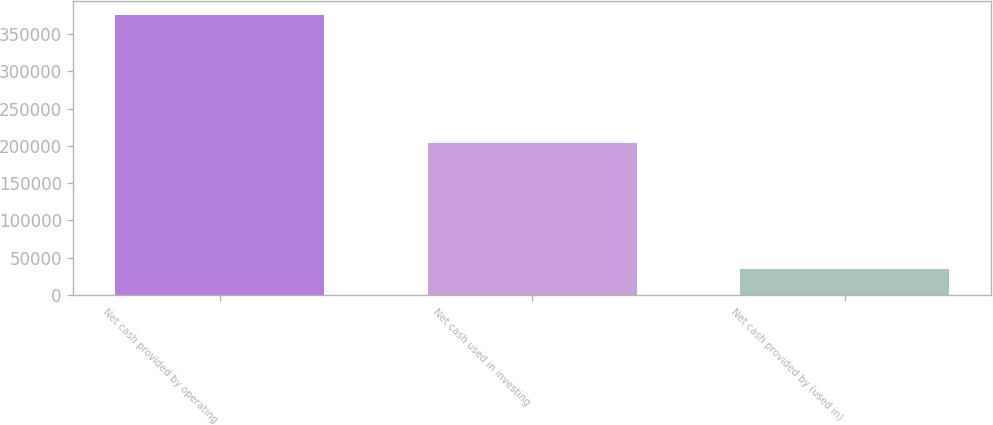Convert chart. <chart><loc_0><loc_0><loc_500><loc_500><bar_chart><fcel>Net cash provided by operating<fcel>Net cash used in investing<fcel>Net cash provided by (used in)<nl><fcel>375721<fcel>204129<fcel>34780<nl></chart> 